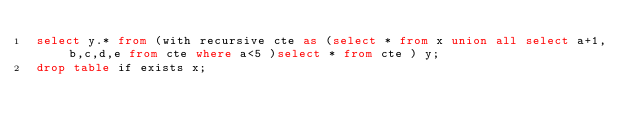Convert code to text. <code><loc_0><loc_0><loc_500><loc_500><_SQL_>select y.* from (with recursive cte as (select * from x union all select a+1,b,c,d,e from cte where a<5 )select * from cte ) y;
drop table if exists x;
</code> 